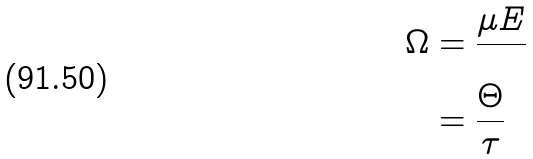Convert formula to latex. <formula><loc_0><loc_0><loc_500><loc_500>\Omega & = \frac { \mu E } { } \\ & = \frac { \Theta } { \tau }</formula> 